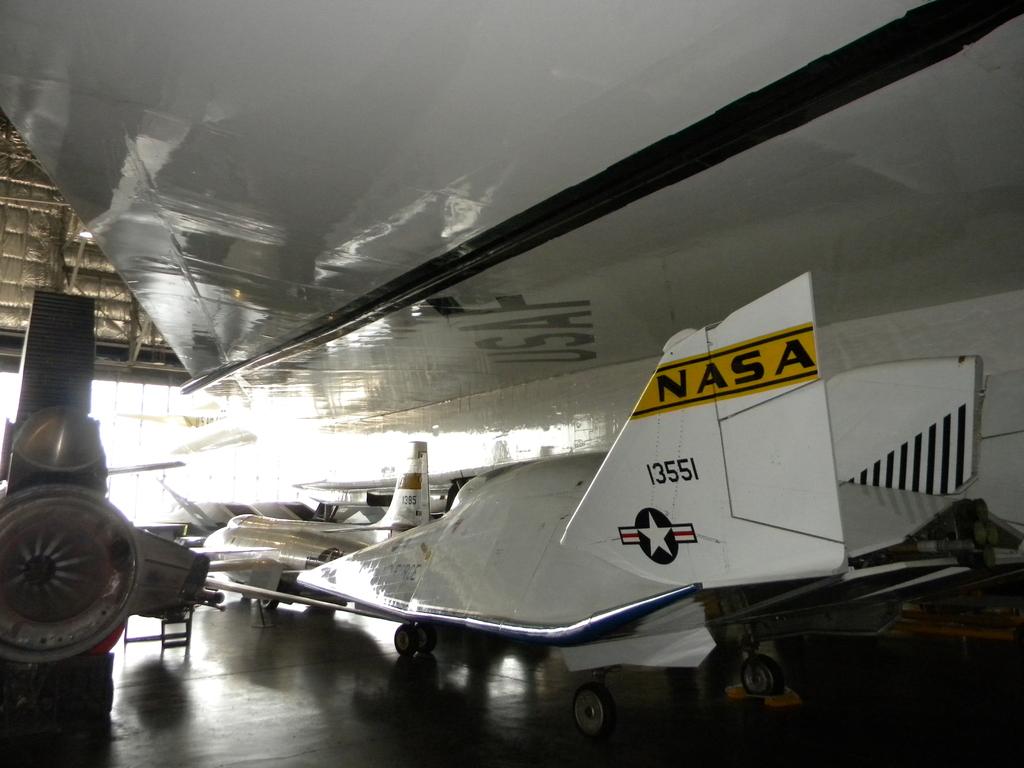Who owns this aircraft?
Ensure brevity in your answer.  Nasa. What is the number of the aircraft?
Provide a short and direct response. 13551. 